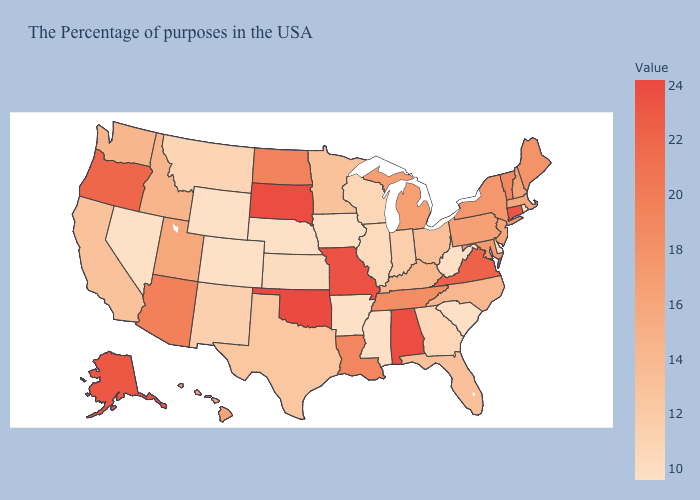Does Rhode Island have the lowest value in the Northeast?
Quick response, please. Yes. Which states have the highest value in the USA?
Quick response, please. Oklahoma. Among the states that border Minnesota , does South Dakota have the highest value?
Answer briefly. Yes. Does Oklahoma have the highest value in the USA?
Give a very brief answer. Yes. Does Wyoming have the lowest value in the West?
Concise answer only. Yes. 